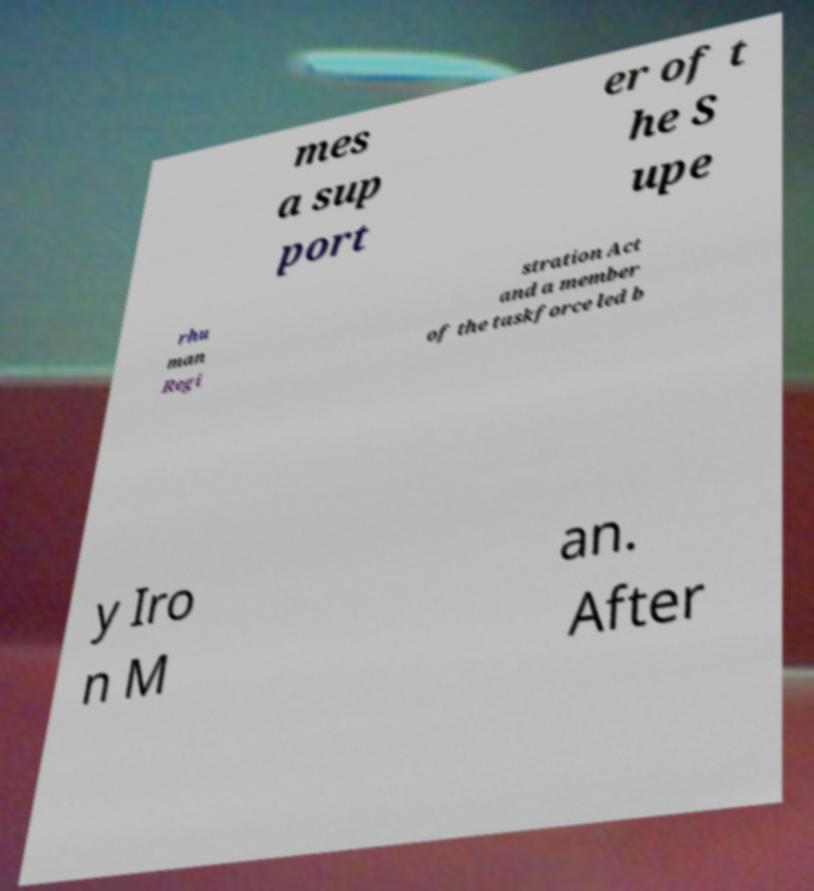For documentation purposes, I need the text within this image transcribed. Could you provide that? mes a sup port er of t he S upe rhu man Regi stration Act and a member of the taskforce led b y Iro n M an. After 